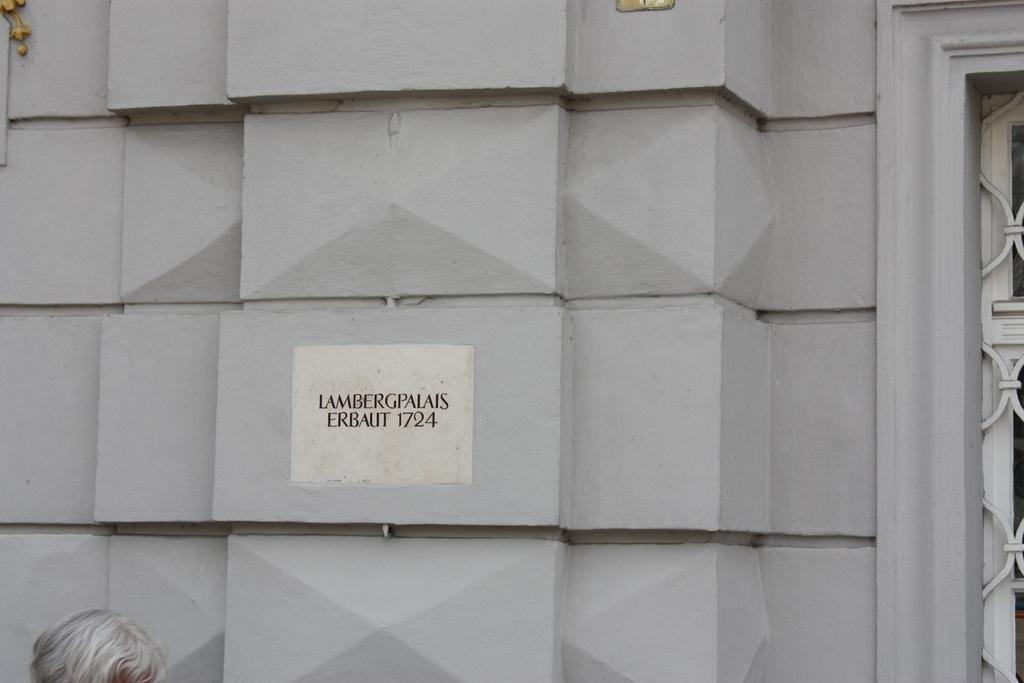What can be seen on the wall in the foreground of the image? There is text on the wall in the foreground of the image. What architectural feature is present on the right side of the image? There appears to be a window on the right side of the image. Can you describe the person's head that is visible at the bottom of the image? A person's head is visible at the bottom of the image. How many eyes can be seen on the person's head in the image? The person's head is only partially visible in the image, so it is impossible to determine the number of eyes. What type of support is the window providing in the image? The window is not providing any support in the image; it is a stationary architectural feature. 